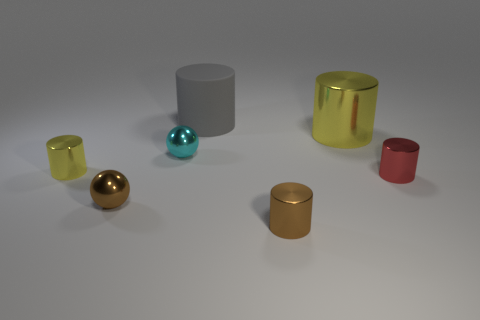Subtract all big yellow cylinders. How many cylinders are left? 4 Subtract all brown spheres. How many spheres are left? 1 Add 2 tiny blue matte cylinders. How many objects exist? 9 Subtract all cylinders. How many objects are left? 2 Subtract 1 cylinders. How many cylinders are left? 4 Subtract all blue spheres. How many brown cylinders are left? 1 Subtract all large shiny balls. Subtract all small brown metal cylinders. How many objects are left? 6 Add 4 small cyan metal spheres. How many small cyan metal spheres are left? 5 Add 1 small gray rubber cylinders. How many small gray rubber cylinders exist? 1 Subtract 0 purple cylinders. How many objects are left? 7 